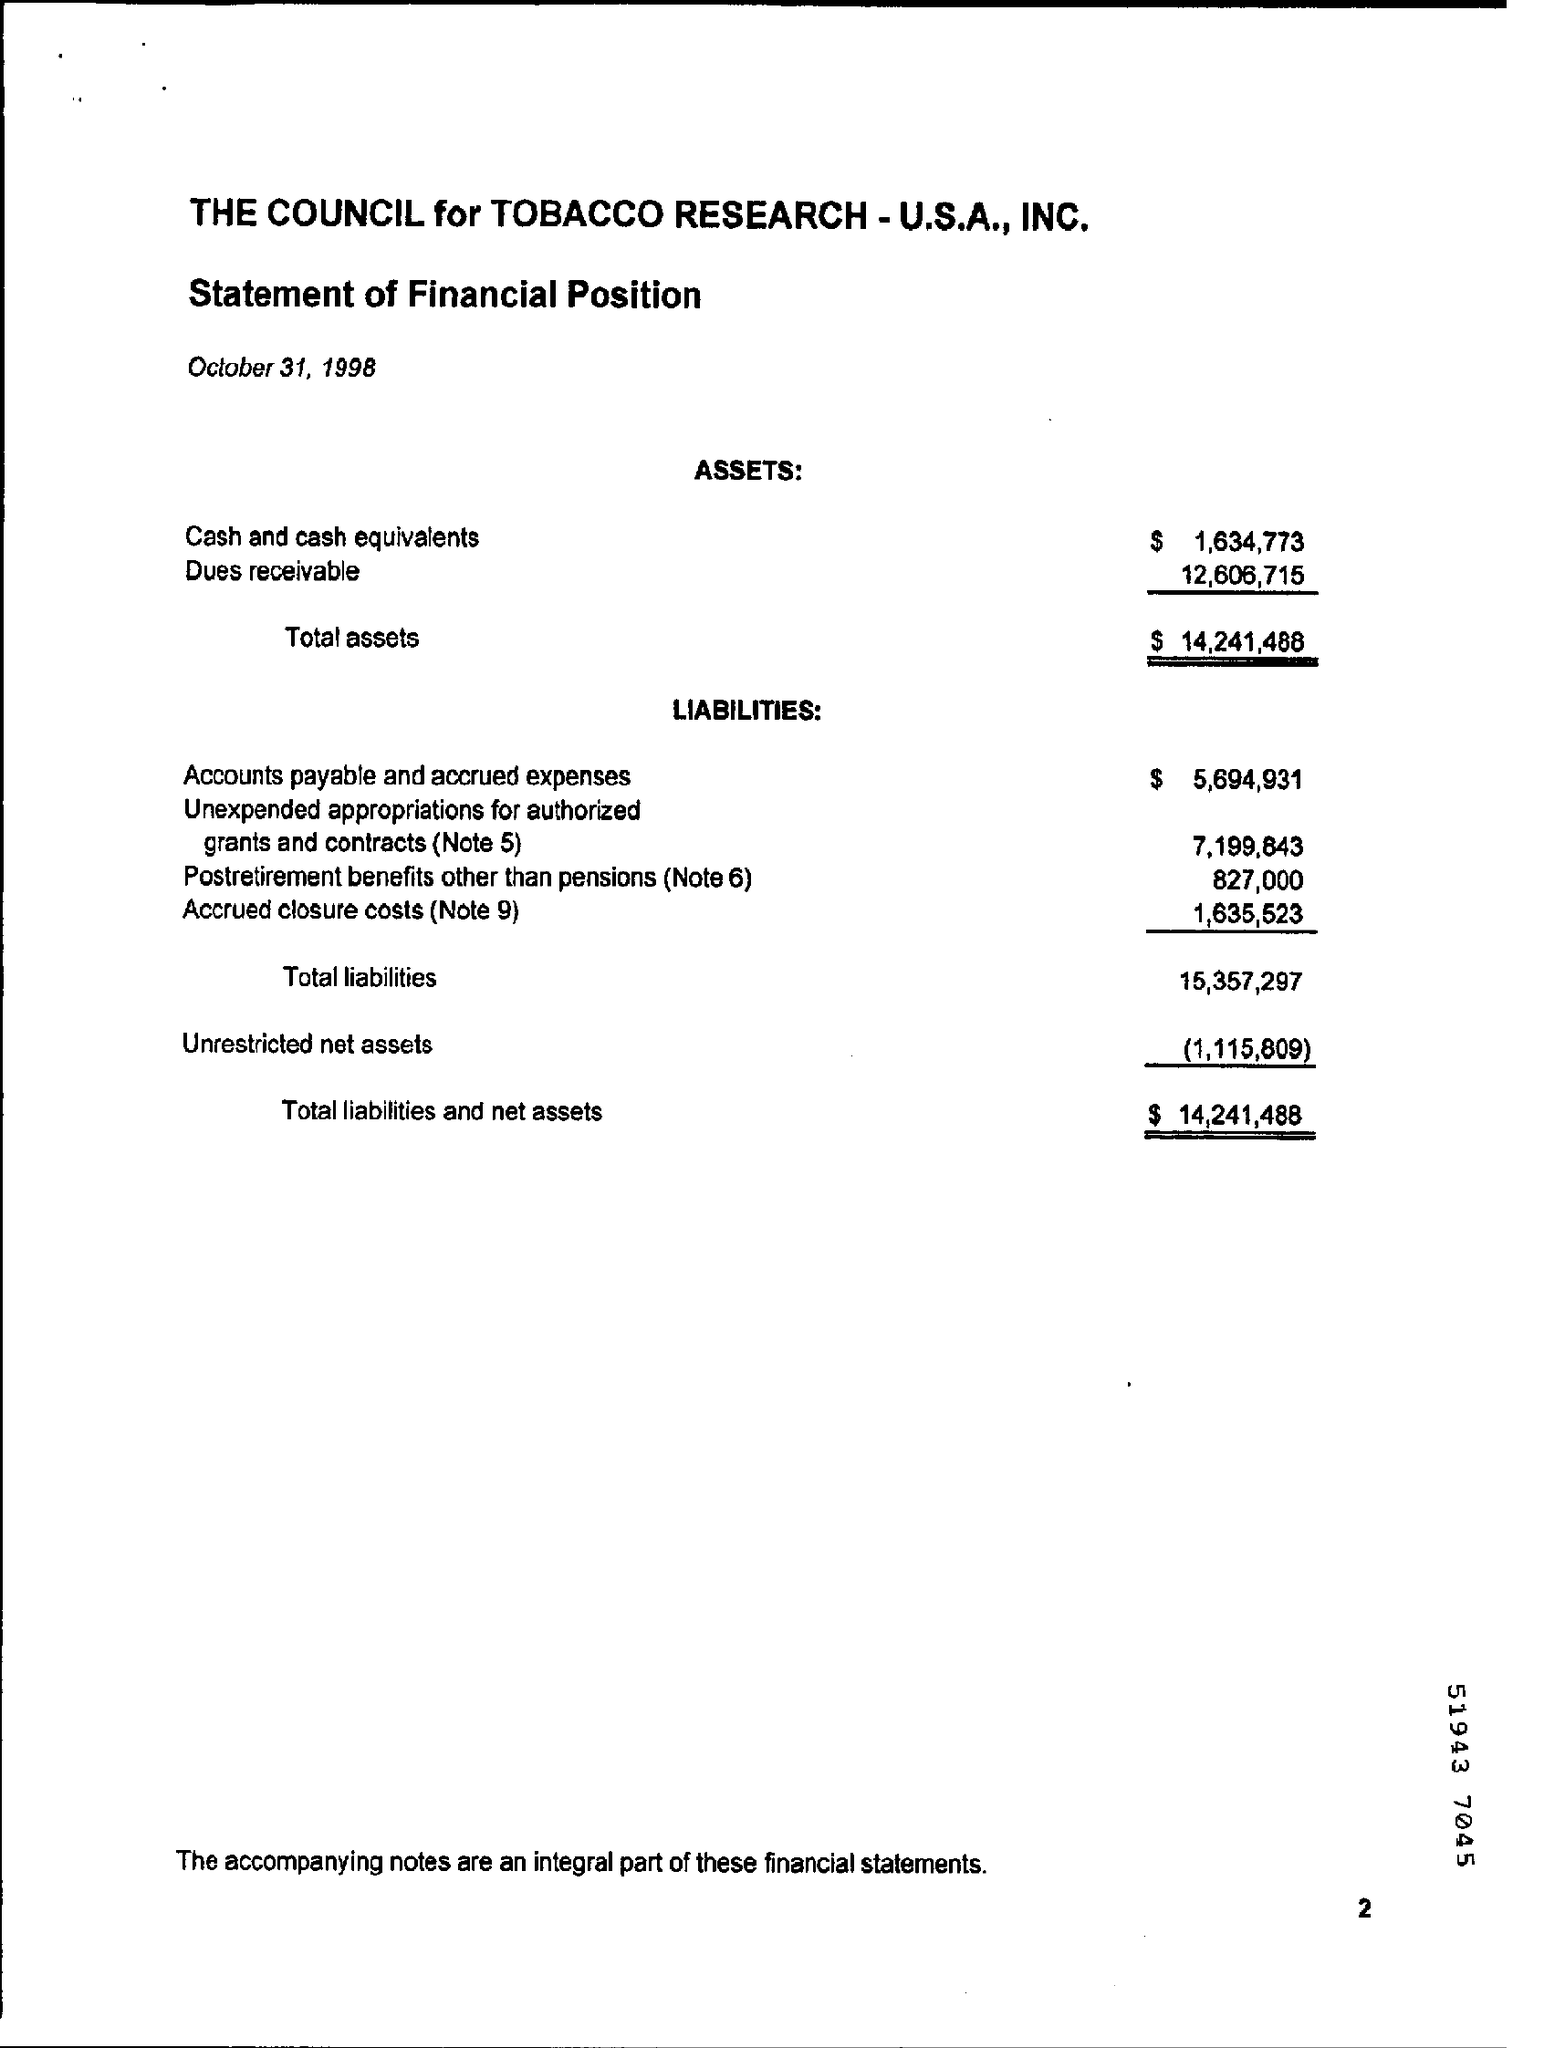What is the document about?
Your response must be concise. Statement of Financial Position. When is the document dated?
Keep it short and to the point. October 31, 1998. What is the total value of assets?
Give a very brief answer. $ 14,241,488. What is the value of Accounts payable and accrued expenses?
Provide a succinct answer. $ 5,694,931. 